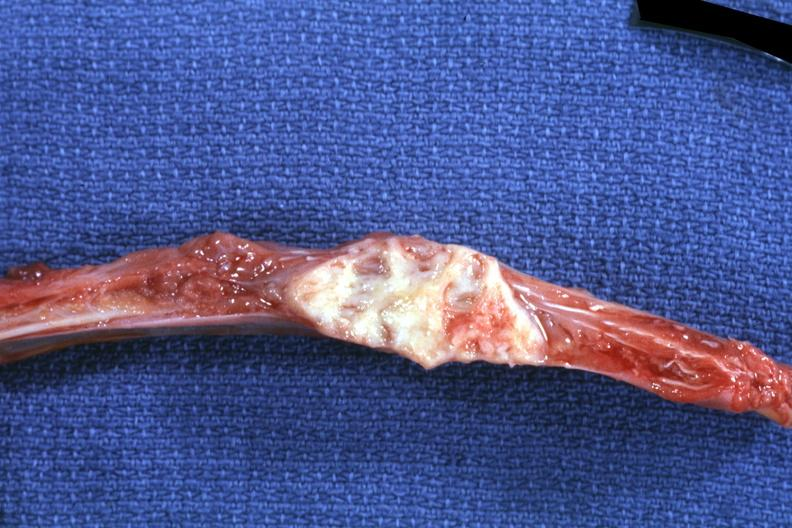what does this image show?
Answer the question using a single word or phrase. Rib with obvious focal lesion squamous cell carcinoma primary in penis 